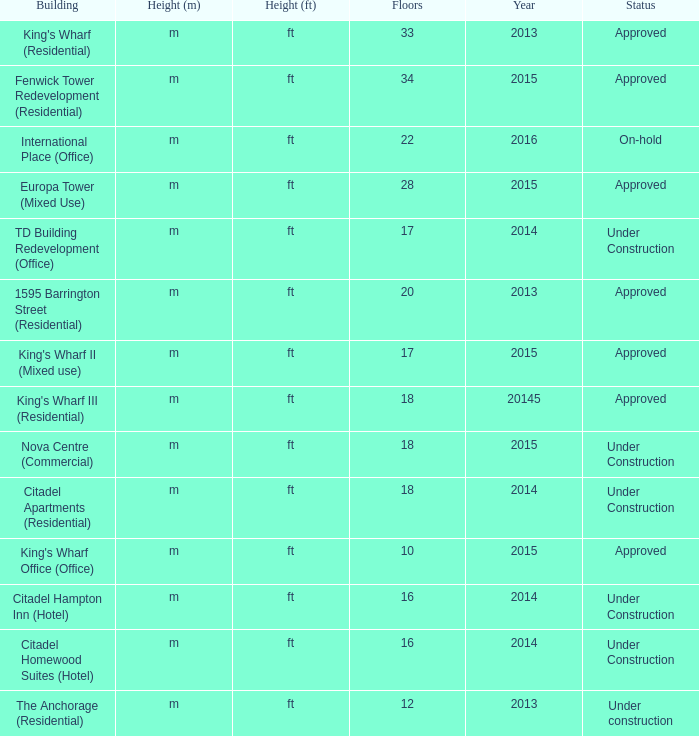What is the status of the building with more than 28 floor and a year of 2013? Approved. 